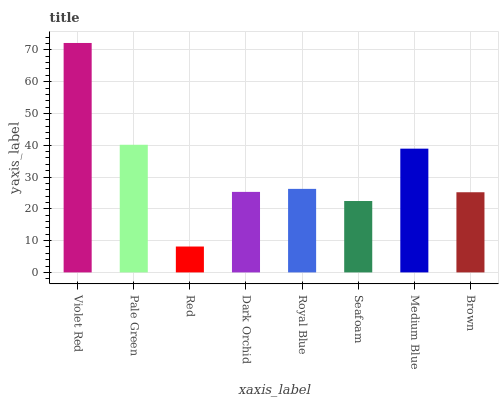Is Red the minimum?
Answer yes or no. Yes. Is Violet Red the maximum?
Answer yes or no. Yes. Is Pale Green the minimum?
Answer yes or no. No. Is Pale Green the maximum?
Answer yes or no. No. Is Violet Red greater than Pale Green?
Answer yes or no. Yes. Is Pale Green less than Violet Red?
Answer yes or no. Yes. Is Pale Green greater than Violet Red?
Answer yes or no. No. Is Violet Red less than Pale Green?
Answer yes or no. No. Is Royal Blue the high median?
Answer yes or no. Yes. Is Dark Orchid the low median?
Answer yes or no. Yes. Is Pale Green the high median?
Answer yes or no. No. Is Pale Green the low median?
Answer yes or no. No. 